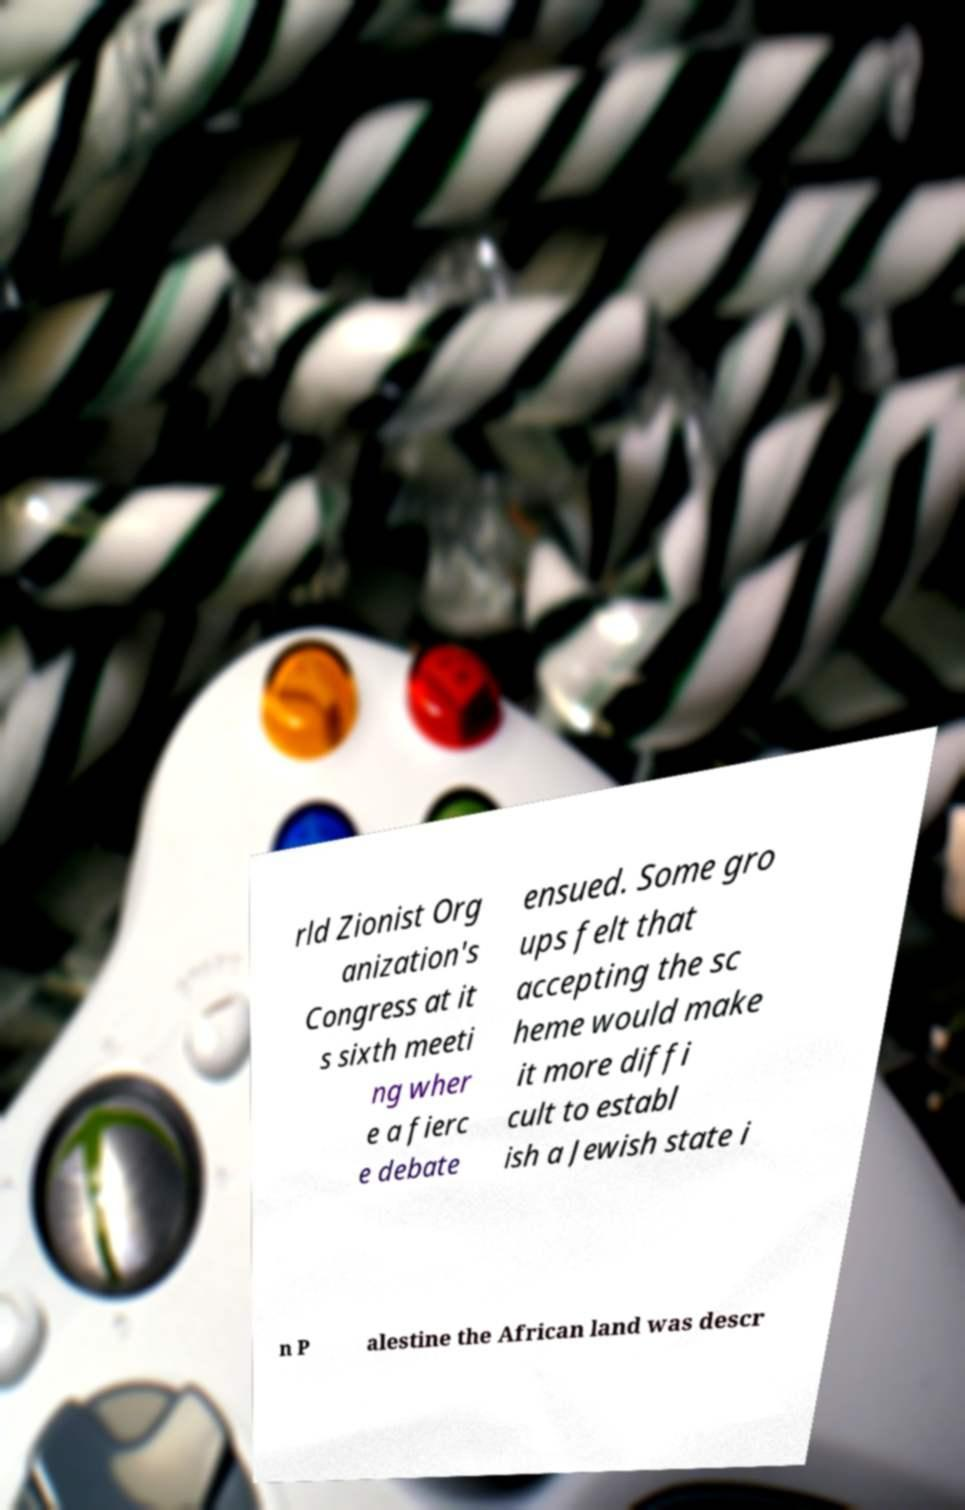Please read and relay the text visible in this image. What does it say? rld Zionist Org anization's Congress at it s sixth meeti ng wher e a fierc e debate ensued. Some gro ups felt that accepting the sc heme would make it more diffi cult to establ ish a Jewish state i n P alestine the African land was descr 